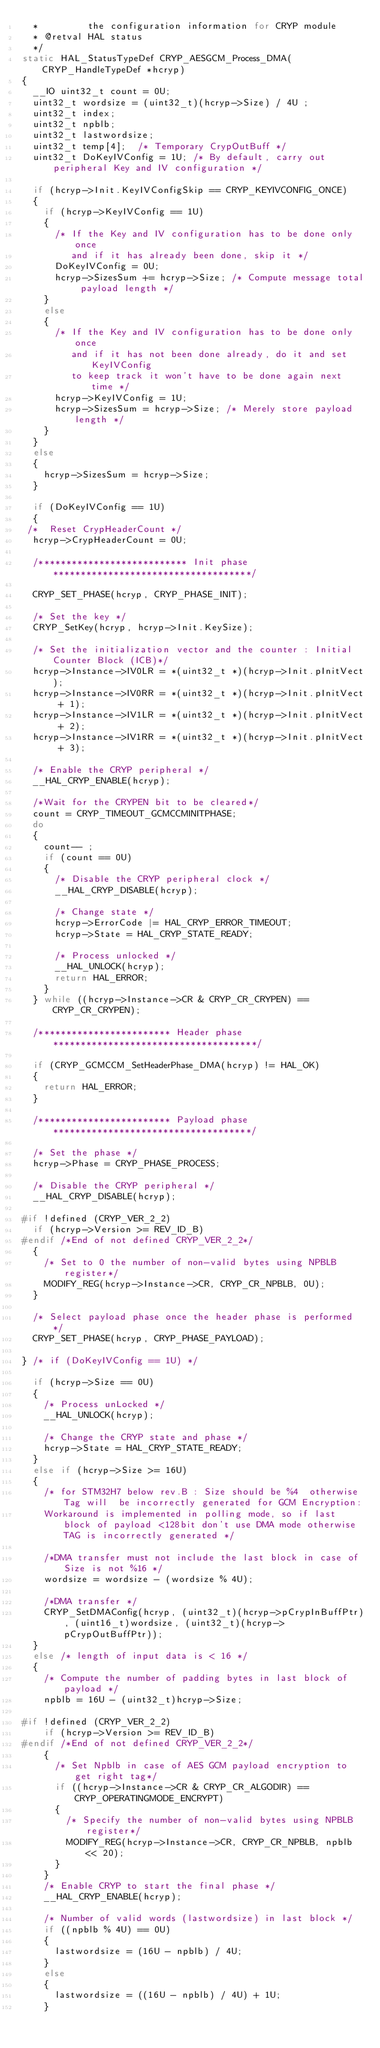Convert code to text. <code><loc_0><loc_0><loc_500><loc_500><_C_>  *         the configuration information for CRYP module
  * @retval HAL status
  */
static HAL_StatusTypeDef CRYP_AESGCM_Process_DMA(CRYP_HandleTypeDef *hcryp)
{
  __IO uint32_t count = 0U;
  uint32_t wordsize = (uint32_t)(hcryp->Size) / 4U ;
  uint32_t index;
  uint32_t npblb;
  uint32_t lastwordsize;
  uint32_t temp[4];  /* Temporary CrypOutBuff */
  uint32_t DoKeyIVConfig = 1U; /* By default, carry out peripheral Key and IV configuration */

  if (hcryp->Init.KeyIVConfigSkip == CRYP_KEYIVCONFIG_ONCE)
  {
    if (hcryp->KeyIVConfig == 1U)
    {
      /* If the Key and IV configuration has to be done only once
         and if it has already been done, skip it */
      DoKeyIVConfig = 0U;
      hcryp->SizesSum += hcryp->Size; /* Compute message total payload length */
    }
    else
    {
      /* If the Key and IV configuration has to be done only once
         and if it has not been done already, do it and set KeyIVConfig
         to keep track it won't have to be done again next time */
      hcryp->KeyIVConfig = 1U;
      hcryp->SizesSum = hcryp->Size; /* Merely store payload length */
    }
  }
  else
  {
    hcryp->SizesSum = hcryp->Size;
  }

  if (DoKeyIVConfig == 1U)
  {
 /*  Reset CrypHeaderCount */
  hcryp->CrypHeaderCount = 0U;

  /*************************** Init phase ************************************/

  CRYP_SET_PHASE(hcryp, CRYP_PHASE_INIT);

  /* Set the key */
  CRYP_SetKey(hcryp, hcryp->Init.KeySize);

  /* Set the initialization vector and the counter : Initial Counter Block (ICB)*/
  hcryp->Instance->IV0LR = *(uint32_t *)(hcryp->Init.pInitVect);
  hcryp->Instance->IV0RR = *(uint32_t *)(hcryp->Init.pInitVect + 1);
  hcryp->Instance->IV1LR = *(uint32_t *)(hcryp->Init.pInitVect + 2);
  hcryp->Instance->IV1RR = *(uint32_t *)(hcryp->Init.pInitVect + 3);

  /* Enable the CRYP peripheral */
  __HAL_CRYP_ENABLE(hcryp);

  /*Wait for the CRYPEN bit to be cleared*/
  count = CRYP_TIMEOUT_GCMCCMINITPHASE;
  do
  {
    count-- ;
    if (count == 0U)
    {
      /* Disable the CRYP peripheral clock */
      __HAL_CRYP_DISABLE(hcryp);

      /* Change state */
      hcryp->ErrorCode |= HAL_CRYP_ERROR_TIMEOUT;
      hcryp->State = HAL_CRYP_STATE_READY;

      /* Process unlocked */
      __HAL_UNLOCK(hcryp);
      return HAL_ERROR;
    }
  } while ((hcryp->Instance->CR & CRYP_CR_CRYPEN) == CRYP_CR_CRYPEN);

  /************************ Header phase *************************************/

  if (CRYP_GCMCCM_SetHeaderPhase_DMA(hcryp) != HAL_OK)
  {
    return HAL_ERROR;
  }

  /************************ Payload phase ************************************/

  /* Set the phase */
  hcryp->Phase = CRYP_PHASE_PROCESS;

  /* Disable the CRYP peripheral */
  __HAL_CRYP_DISABLE(hcryp);

#if !defined (CRYP_VER_2_2)
  if (hcryp->Version >= REV_ID_B)
#endif /*End of not defined CRYP_VER_2_2*/
  {
    /* Set to 0 the number of non-valid bytes using NPBLB register*/
    MODIFY_REG(hcryp->Instance->CR, CRYP_CR_NPBLB, 0U);
  }

  /* Select payload phase once the header phase is performed */
  CRYP_SET_PHASE(hcryp, CRYP_PHASE_PAYLOAD);

} /* if (DoKeyIVConfig == 1U) */

  if (hcryp->Size == 0U)
  {
    /* Process unLocked */
    __HAL_UNLOCK(hcryp);

    /* Change the CRYP state and phase */
    hcryp->State = HAL_CRYP_STATE_READY;
  }
  else if (hcryp->Size >= 16U)
  {
    /* for STM32H7 below rev.B : Size should be %4  otherwise Tag will  be incorrectly generated for GCM Encryption:
    Workaround is implemented in polling mode, so if last block of payload <128bit don't use DMA mode otherwise TAG is incorrectly generated */

    /*DMA transfer must not include the last block in case of Size is not %16 */
    wordsize = wordsize - (wordsize % 4U);

    /*DMA transfer */
    CRYP_SetDMAConfig(hcryp, (uint32_t)(hcryp->pCrypInBuffPtr), (uint16_t)wordsize, (uint32_t)(hcryp->pCrypOutBuffPtr));
  }
  else /* length of input data is < 16 */
  {
    /* Compute the number of padding bytes in last block of payload */
    npblb = 16U - (uint32_t)hcryp->Size;

#if !defined (CRYP_VER_2_2)
    if (hcryp->Version >= REV_ID_B)
#endif /*End of not defined CRYP_VER_2_2*/
    {
      /* Set Npblb in case of AES GCM payload encryption to get right tag*/
      if ((hcryp->Instance->CR & CRYP_CR_ALGODIR) == CRYP_OPERATINGMODE_ENCRYPT)
      {
        /* Specify the number of non-valid bytes using NPBLB register*/
        MODIFY_REG(hcryp->Instance->CR, CRYP_CR_NPBLB, npblb << 20);
      }
    }
    /* Enable CRYP to start the final phase */
    __HAL_CRYP_ENABLE(hcryp);

    /* Number of valid words (lastwordsize) in last block */
    if ((npblb % 4U) == 0U)
    {
      lastwordsize = (16U - npblb) / 4U;
    }
    else
    {
      lastwordsize = ((16U - npblb) / 4U) + 1U;
    }
</code> 